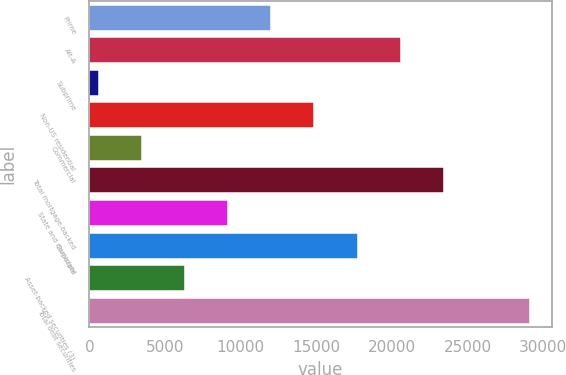<chart> <loc_0><loc_0><loc_500><loc_500><bar_chart><fcel>Prime<fcel>Alt-A<fcel>Subprime<fcel>Non-US residential<fcel>Commercial<fcel>Total mortgage-backed<fcel>State and municipal<fcel>Corporate<fcel>Asset-backed securities (3)<fcel>Total debt securities<nl><fcel>12022.6<fcel>20564.8<fcel>633<fcel>14870<fcel>3480.4<fcel>23412.2<fcel>9175.2<fcel>17717.4<fcel>6327.8<fcel>29107<nl></chart> 